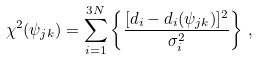Convert formula to latex. <formula><loc_0><loc_0><loc_500><loc_500>\chi ^ { 2 } ( \psi _ { j k } ) = \sum _ { i = 1 } ^ { 3 N } \left \{ \frac { [ d _ { i } - d _ { i } ( \psi _ { j k } ) ] ^ { 2 } } { \sigma _ { i } ^ { 2 } } \right \} \, ,</formula> 